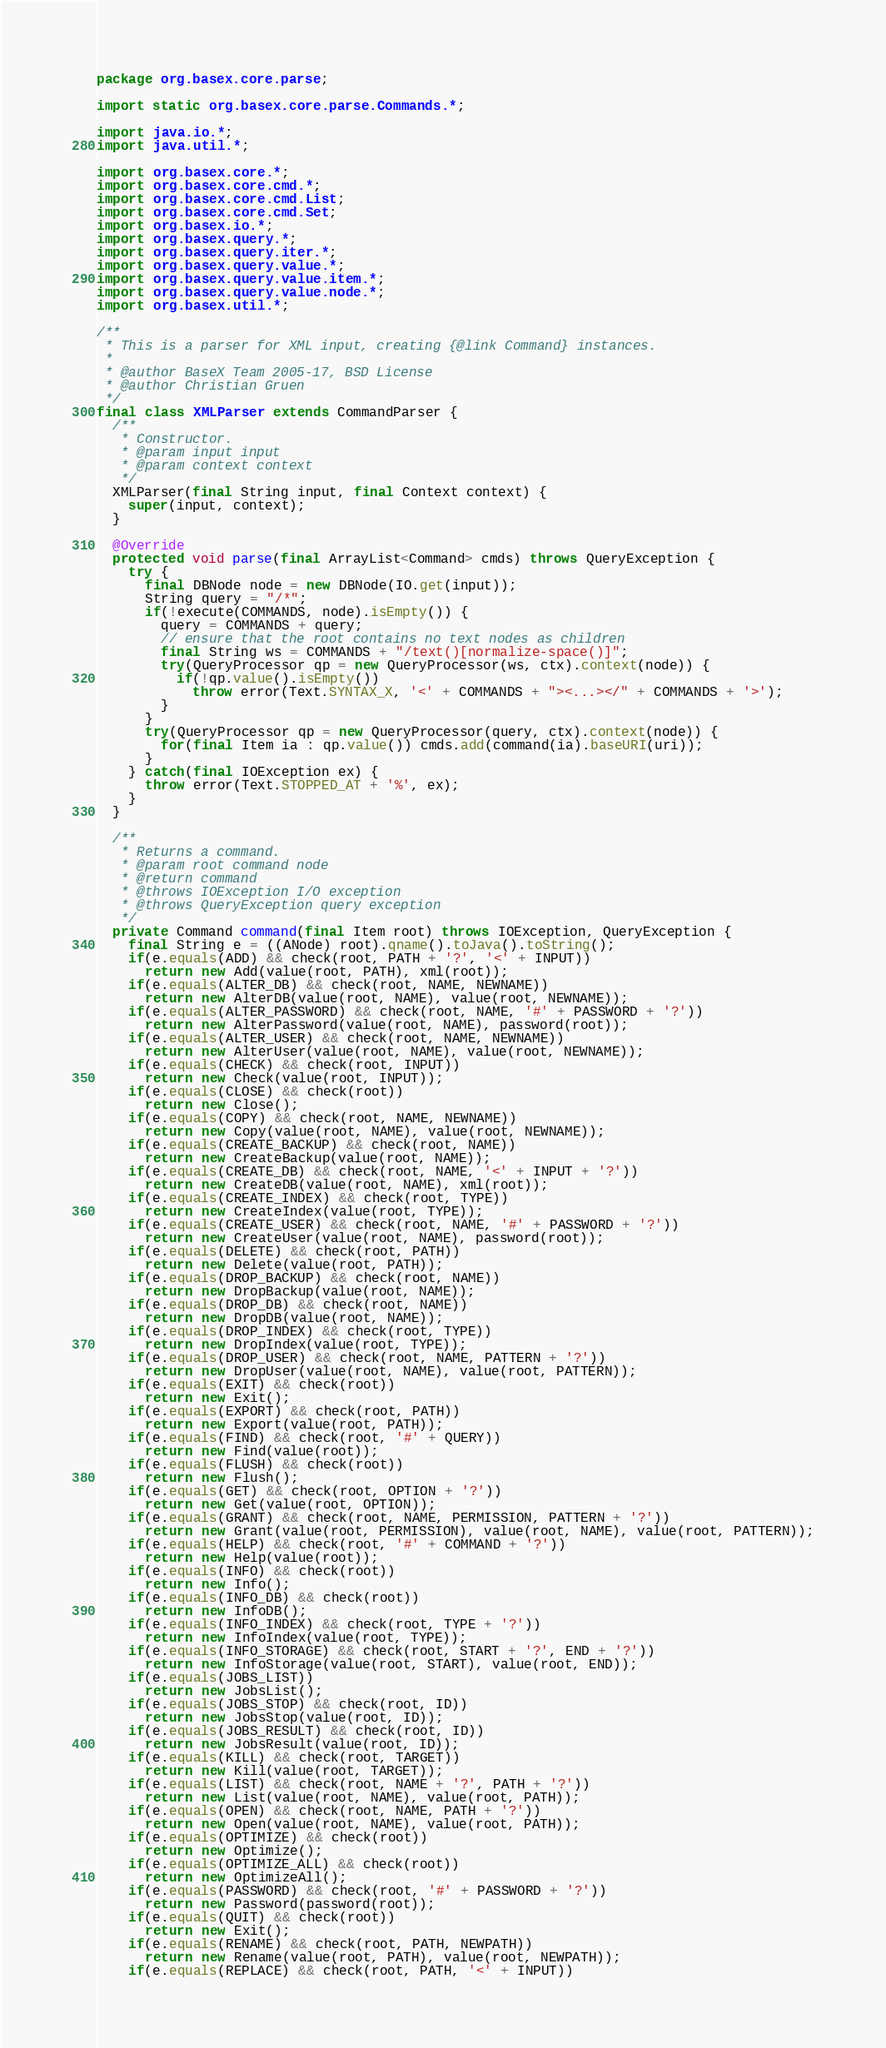<code> <loc_0><loc_0><loc_500><loc_500><_Java_>package org.basex.core.parse;

import static org.basex.core.parse.Commands.*;

import java.io.*;
import java.util.*;

import org.basex.core.*;
import org.basex.core.cmd.*;
import org.basex.core.cmd.List;
import org.basex.core.cmd.Set;
import org.basex.io.*;
import org.basex.query.*;
import org.basex.query.iter.*;
import org.basex.query.value.*;
import org.basex.query.value.item.*;
import org.basex.query.value.node.*;
import org.basex.util.*;

/**
 * This is a parser for XML input, creating {@link Command} instances.
 *
 * @author BaseX Team 2005-17, BSD License
 * @author Christian Gruen
 */
final class XMLParser extends CommandParser {
  /**
   * Constructor.
   * @param input input
   * @param context context
   */
  XMLParser(final String input, final Context context) {
    super(input, context);
  }

  @Override
  protected void parse(final ArrayList<Command> cmds) throws QueryException {
    try {
      final DBNode node = new DBNode(IO.get(input));
      String query = "/*";
      if(!execute(COMMANDS, node).isEmpty()) {
        query = COMMANDS + query;
        // ensure that the root contains no text nodes as children
        final String ws = COMMANDS + "/text()[normalize-space()]";
        try(QueryProcessor qp = new QueryProcessor(ws, ctx).context(node)) {
          if(!qp.value().isEmpty())
            throw error(Text.SYNTAX_X, '<' + COMMANDS + "><...></" + COMMANDS + '>');
        }
      }
      try(QueryProcessor qp = new QueryProcessor(query, ctx).context(node)) {
        for(final Item ia : qp.value()) cmds.add(command(ia).baseURI(uri));
      }
    } catch(final IOException ex) {
      throw error(Text.STOPPED_AT + '%', ex);
    }
  }

  /**
   * Returns a command.
   * @param root command node
   * @return command
   * @throws IOException I/O exception
   * @throws QueryException query exception
   */
  private Command command(final Item root) throws IOException, QueryException {
    final String e = ((ANode) root).qname().toJava().toString();
    if(e.equals(ADD) && check(root, PATH + '?', '<' + INPUT))
      return new Add(value(root, PATH), xml(root));
    if(e.equals(ALTER_DB) && check(root, NAME, NEWNAME))
      return new AlterDB(value(root, NAME), value(root, NEWNAME));
    if(e.equals(ALTER_PASSWORD) && check(root, NAME, '#' + PASSWORD + '?'))
      return new AlterPassword(value(root, NAME), password(root));
    if(e.equals(ALTER_USER) && check(root, NAME, NEWNAME))
      return new AlterUser(value(root, NAME), value(root, NEWNAME));
    if(e.equals(CHECK) && check(root, INPUT))
      return new Check(value(root, INPUT));
    if(e.equals(CLOSE) && check(root))
      return new Close();
    if(e.equals(COPY) && check(root, NAME, NEWNAME))
      return new Copy(value(root, NAME), value(root, NEWNAME));
    if(e.equals(CREATE_BACKUP) && check(root, NAME))
      return new CreateBackup(value(root, NAME));
    if(e.equals(CREATE_DB) && check(root, NAME, '<' + INPUT + '?'))
      return new CreateDB(value(root, NAME), xml(root));
    if(e.equals(CREATE_INDEX) && check(root, TYPE))
      return new CreateIndex(value(root, TYPE));
    if(e.equals(CREATE_USER) && check(root, NAME, '#' + PASSWORD + '?'))
      return new CreateUser(value(root, NAME), password(root));
    if(e.equals(DELETE) && check(root, PATH))
      return new Delete(value(root, PATH));
    if(e.equals(DROP_BACKUP) && check(root, NAME))
      return new DropBackup(value(root, NAME));
    if(e.equals(DROP_DB) && check(root, NAME))
      return new DropDB(value(root, NAME));
    if(e.equals(DROP_INDEX) && check(root, TYPE))
      return new DropIndex(value(root, TYPE));
    if(e.equals(DROP_USER) && check(root, NAME, PATTERN + '?'))
      return new DropUser(value(root, NAME), value(root, PATTERN));
    if(e.equals(EXIT) && check(root))
      return new Exit();
    if(e.equals(EXPORT) && check(root, PATH))
      return new Export(value(root, PATH));
    if(e.equals(FIND) && check(root, '#' + QUERY))
      return new Find(value(root));
    if(e.equals(FLUSH) && check(root))
      return new Flush();
    if(e.equals(GET) && check(root, OPTION + '?'))
      return new Get(value(root, OPTION));
    if(e.equals(GRANT) && check(root, NAME, PERMISSION, PATTERN + '?'))
      return new Grant(value(root, PERMISSION), value(root, NAME), value(root, PATTERN));
    if(e.equals(HELP) && check(root, '#' + COMMAND + '?'))
      return new Help(value(root));
    if(e.equals(INFO) && check(root))
      return new Info();
    if(e.equals(INFO_DB) && check(root))
      return new InfoDB();
    if(e.equals(INFO_INDEX) && check(root, TYPE + '?'))
      return new InfoIndex(value(root, TYPE));
    if(e.equals(INFO_STORAGE) && check(root, START + '?', END + '?'))
      return new InfoStorage(value(root, START), value(root, END));
    if(e.equals(JOBS_LIST))
      return new JobsList();
    if(e.equals(JOBS_STOP) && check(root, ID))
      return new JobsStop(value(root, ID));
    if(e.equals(JOBS_RESULT) && check(root, ID))
      return new JobsResult(value(root, ID));
    if(e.equals(KILL) && check(root, TARGET))
      return new Kill(value(root, TARGET));
    if(e.equals(LIST) && check(root, NAME + '?', PATH + '?'))
      return new List(value(root, NAME), value(root, PATH));
    if(e.equals(OPEN) && check(root, NAME, PATH + '?'))
      return new Open(value(root, NAME), value(root, PATH));
    if(e.equals(OPTIMIZE) && check(root))
      return new Optimize();
    if(e.equals(OPTIMIZE_ALL) && check(root))
      return new OptimizeAll();
    if(e.equals(PASSWORD) && check(root, '#' + PASSWORD + '?'))
      return new Password(password(root));
    if(e.equals(QUIT) && check(root))
      return new Exit();
    if(e.equals(RENAME) && check(root, PATH, NEWPATH))
      return new Rename(value(root, PATH), value(root, NEWPATH));
    if(e.equals(REPLACE) && check(root, PATH, '<' + INPUT))</code> 